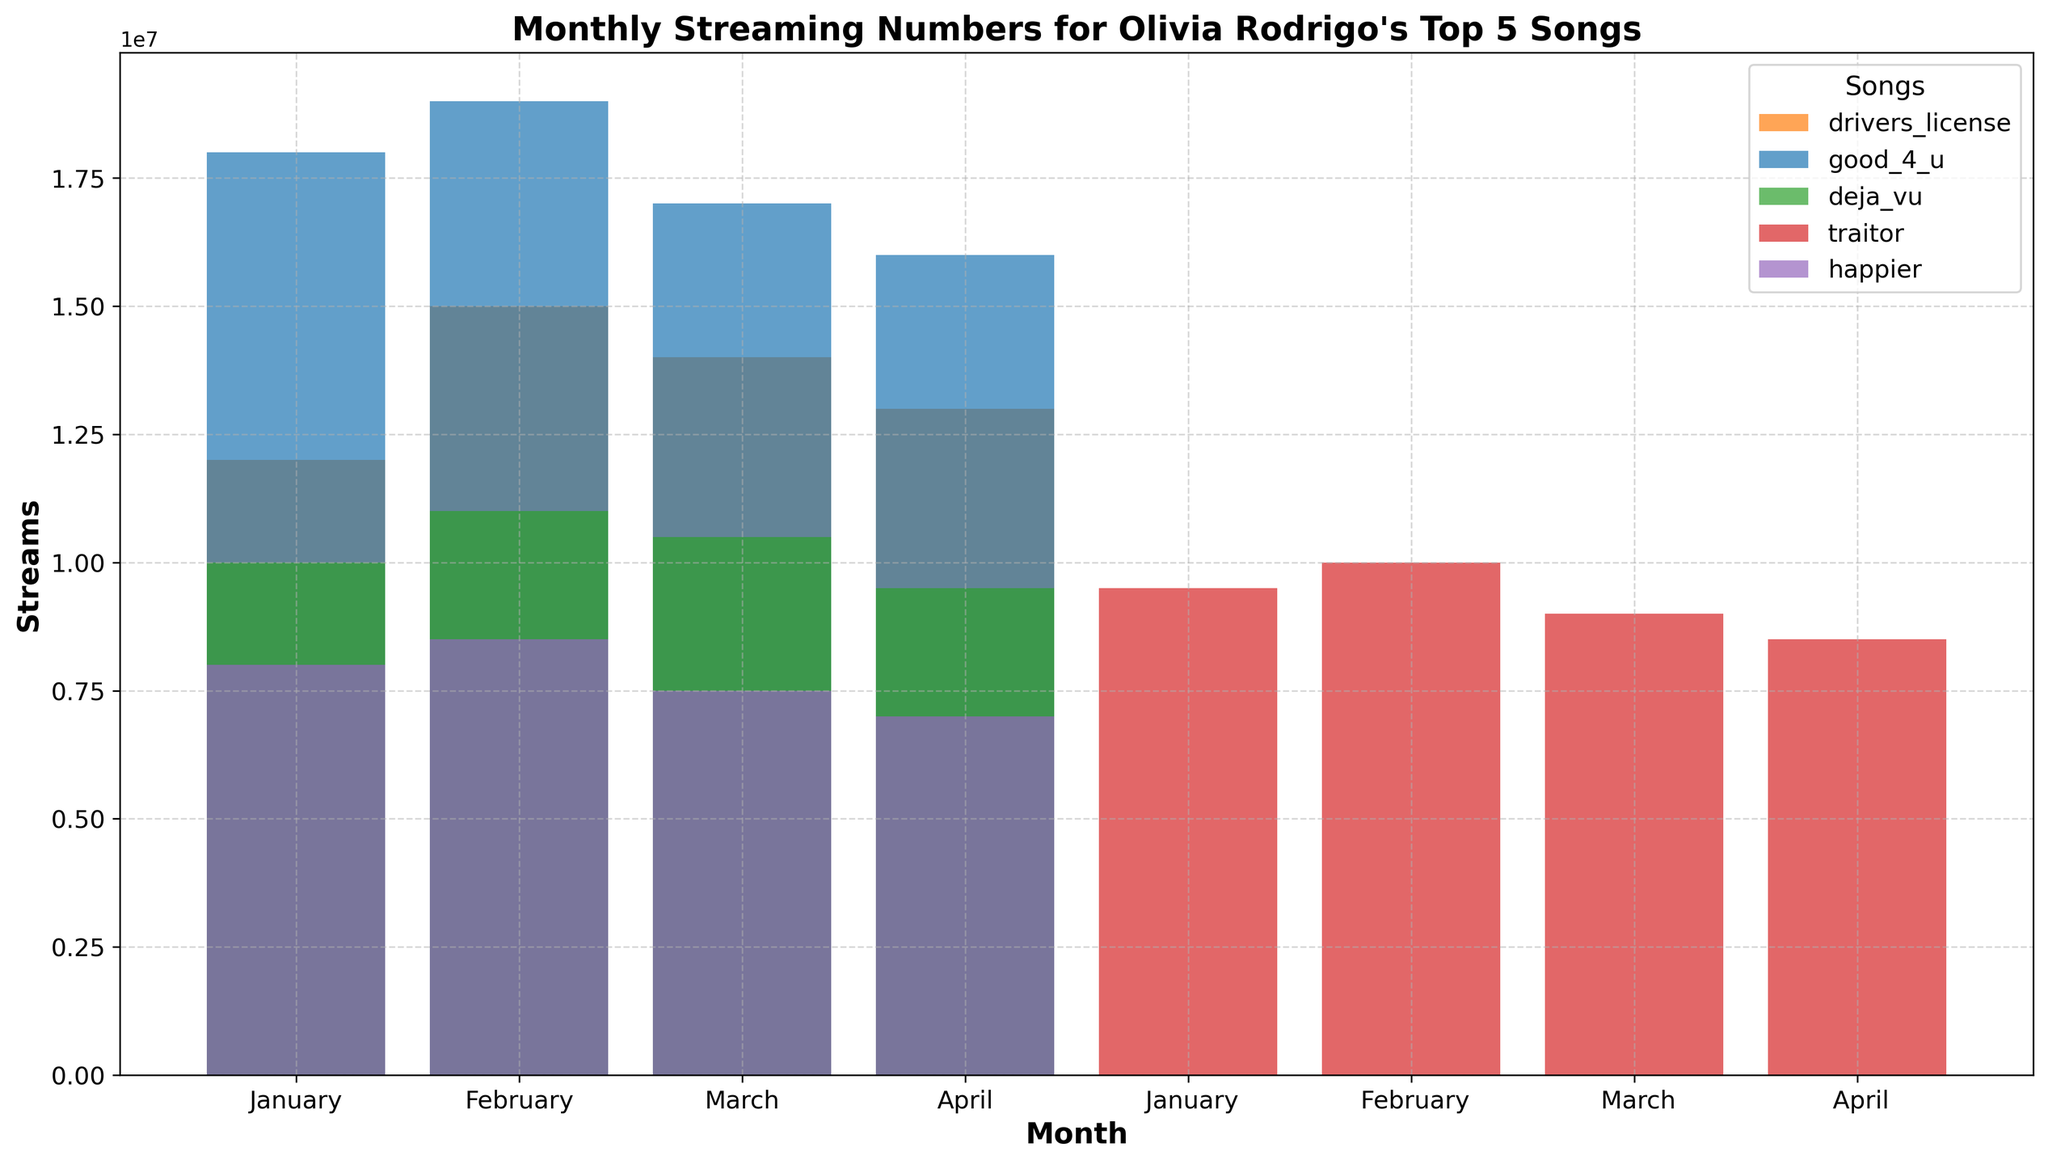Which song had the highest streams in January? In the figure, the bar for "good 4 u" in January is the highest compared to the other songs.
Answer: good 4 u Which song showed an increase in streams from January to February? By inspecting the bars for each song from January to February, all songs "drivers license", "good 4 u", "deja vu", "traitor", and "happier" showed an increase in streams.
Answer: drivers license, good 4 u, deja vu, traitor, happier What is the total number of streams for "traitor" across all months? Add the heights of the bars for "traitor" across all months: January (9.5M) + February (10M) + March (9M) + April (8.5M) = 37M.
Answer: 37M Between "drivers license" and "good 4 u", which song had more streams on average per month? Calculate the average streams per month for both songs:
- drivers license: (12M + 15M + 14M + 13M) / 4 = 54M / 4 = 13.5M
- good 4 u: (18M + 19M + 17M + 16M) / 4 = 70M / 4 = 17.5M 
So, "good 4 u" had more streams on average.
Answer: good 4 u Which song had a noticeable drop in streams from March to April? "drivers license" decreased from 14M to 13M, "good 4 u" from 17M to 16M, "deja vu" from 10.5M to 9.5M, "traitor" from 9M to 8.5M, and "happier" from 7.5M to 7M. Notice "deja vu" had a drop of 1M, which is more evident.
Answer: deja vu Which month had the highest total streams across all songs? Sum the streams for each month and compare:
- January: (12M + 18M + 10M + 9.5M + 8M) = 57.5M
- February: (15M + 19M + 11M + 10M + 8.5M) = 63.5M
- March: (14M + 17M + 10.5M + 9M + 7.5M) = 58M
- April: (13M + 16M + 9.5M + 8.5M + 7M) = 54M
February had the highest total streams.
Answer: February Which song had the lowest streams in April? In April, "happier" had the lowest bar height compared to the other songs.
Answer: happier By how much did the streams for "deja vu" change from January to April? Subtract the streams of "deja vu" in January from its streams in April: 10M (January) - 9.5M (April) = 0.5M decrease.
Answer: 0.5M decrease 